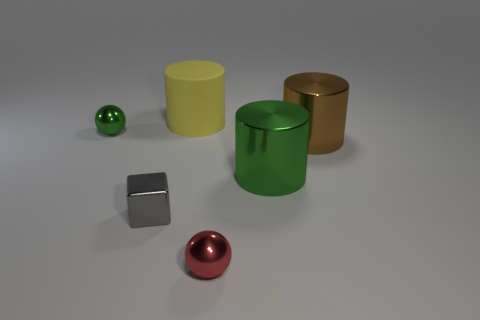There is a object that is left of the rubber cylinder and behind the small gray shiny block; what color is it?
Give a very brief answer. Green. What number of tiny cubes are the same color as the large matte object?
Offer a terse response. 0. There is a big brown metallic thing; is its shape the same as the object that is on the left side of the shiny block?
Provide a succinct answer. No. The object on the right side of the green shiny thing on the right side of the cylinder that is to the left of the red metal thing is what color?
Make the answer very short. Brown. There is a small red object; are there any large cylinders to the right of it?
Your response must be concise. Yes. Is there a large yellow cylinder that has the same material as the green ball?
Make the answer very short. No. The tiny cube has what color?
Provide a succinct answer. Gray. Is the shape of the yellow object on the left side of the big brown cylinder the same as  the brown thing?
Offer a terse response. Yes. The large metallic object behind the big thing that is in front of the large brown cylinder that is to the right of the tiny red object is what shape?
Provide a short and direct response. Cylinder. What material is the ball in front of the big green metallic cylinder?
Your answer should be compact. Metal. 